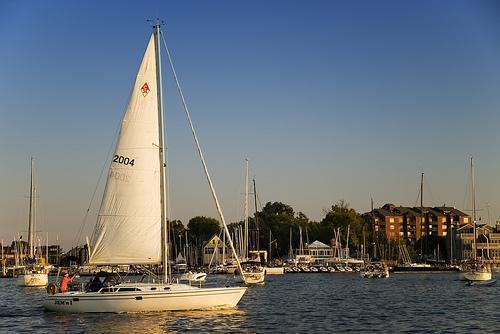How many boats are there?
Give a very brief answer. 6. 